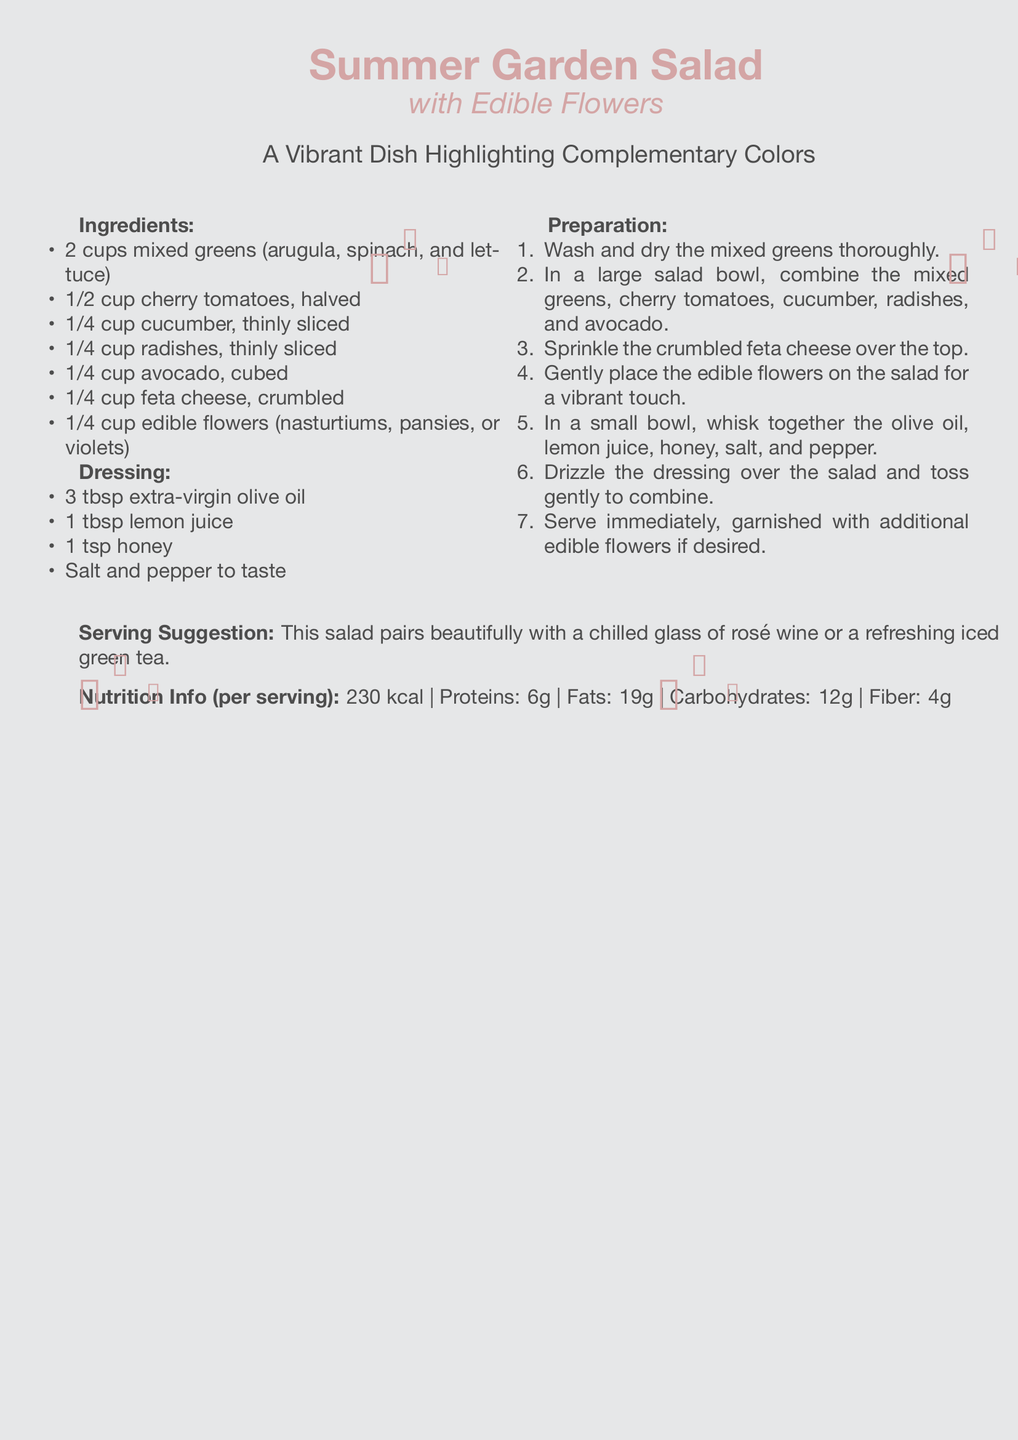what are the main greens used in the salad? The greens listed are arugula, spinach, and lettuce, which are found in the ingredients section.
Answer: mixed greens (arugula, spinach, and lettuce) how many tablespoons of olive oil are needed for the dressing? The recipe specifies 3 tablespoons of olive oil in the dressing section.
Answer: 3 tbsp which edible flowers are suggested for the salad? The document names nasturtiums, pansies, and violets as options in the ingredients list.
Answer: nasturtiums, pansies, or violets what is a suggested beverage to pair with the salad? The serving suggestion mentions a chilled glass of rosé wine or refreshing iced green tea.
Answer: rosé wine or iced green tea how many calories are in one serving of the salad? The nutrition info states the salad contains 230 kcal per serving.
Answer: 230 kcal what type of cuisine does this recipe represent? The presence of fresh greens, vegetables, and edible flowers indicates this is a salad, commonly associated with light, summer cuisine.
Answer: summer cuisine how many steps are there in the preparation? The preparation section contains 7 steps listed in an enumerated format.
Answer: 7 steps what color is the background of the document? The background color is specified as a light grey tone in the document's setup.
Answer: light grey 